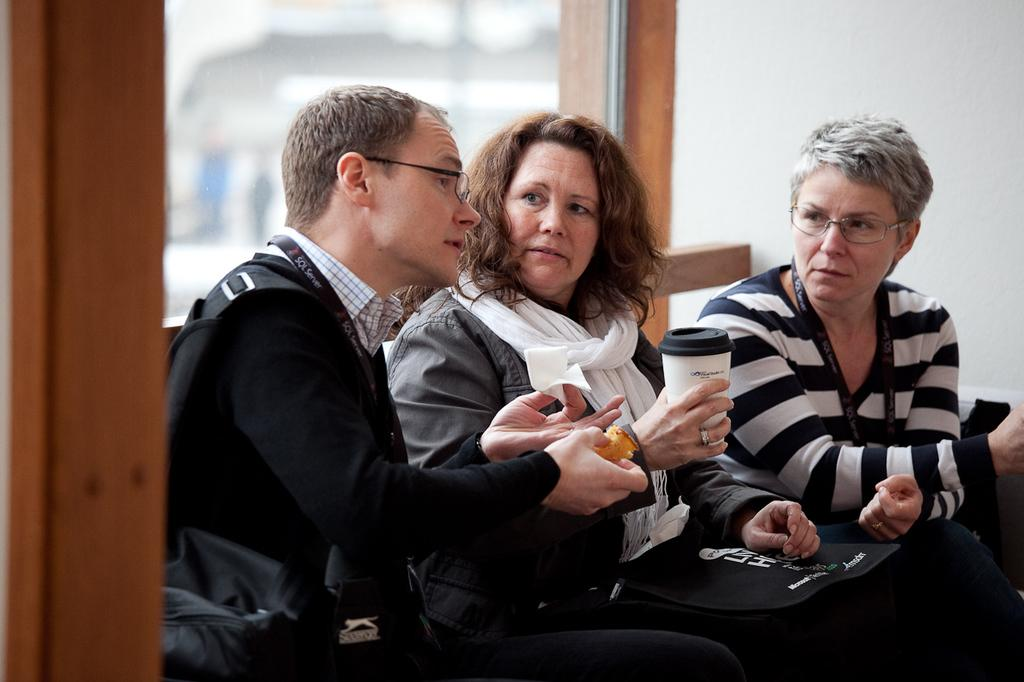What are the people in the image doing? The people in the image are sitting. What can be seen on the people's clothing? The people are wearing ID cards. What are the people holding in the image? The people are holding objects. What is visible in the background of the image? There is a wall in the background of the image. What type of lumber is being used to build the surprise in the image? There is no lumber or surprise present in the image. 